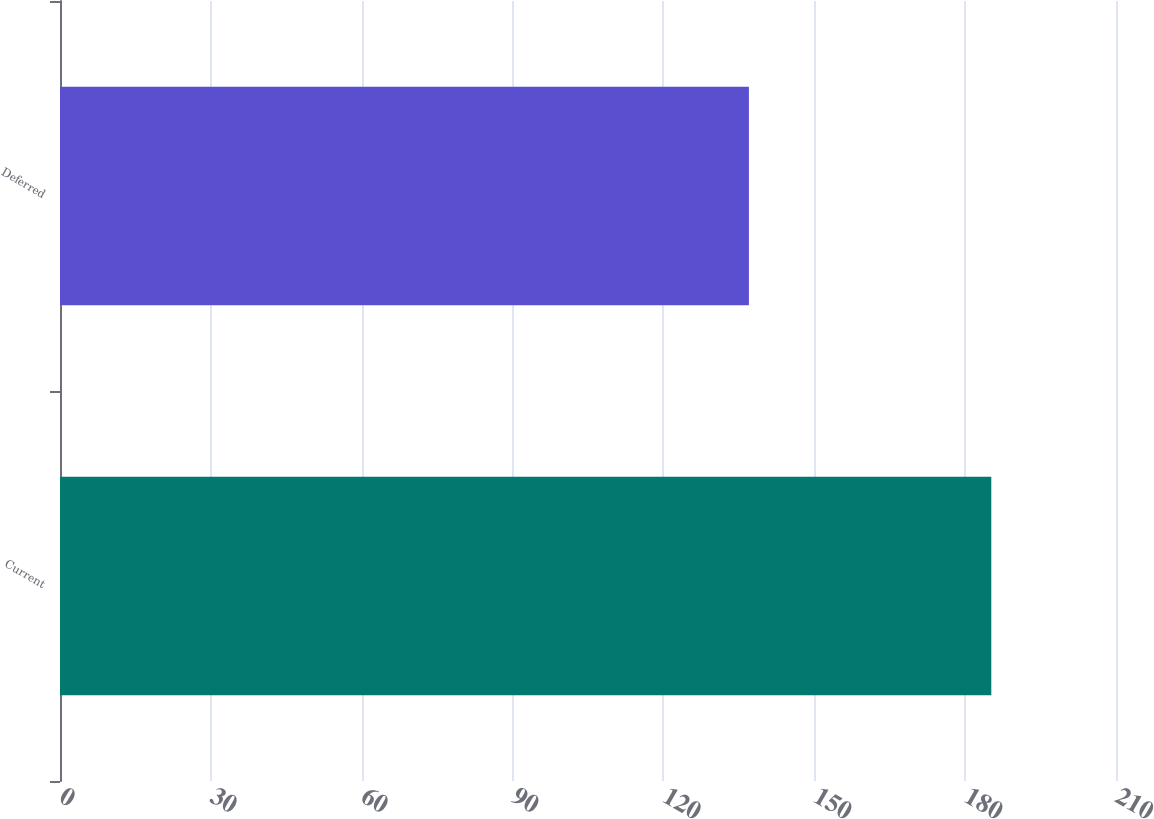Convert chart to OTSL. <chart><loc_0><loc_0><loc_500><loc_500><bar_chart><fcel>Current<fcel>Deferred<nl><fcel>185.2<fcel>137<nl></chart> 